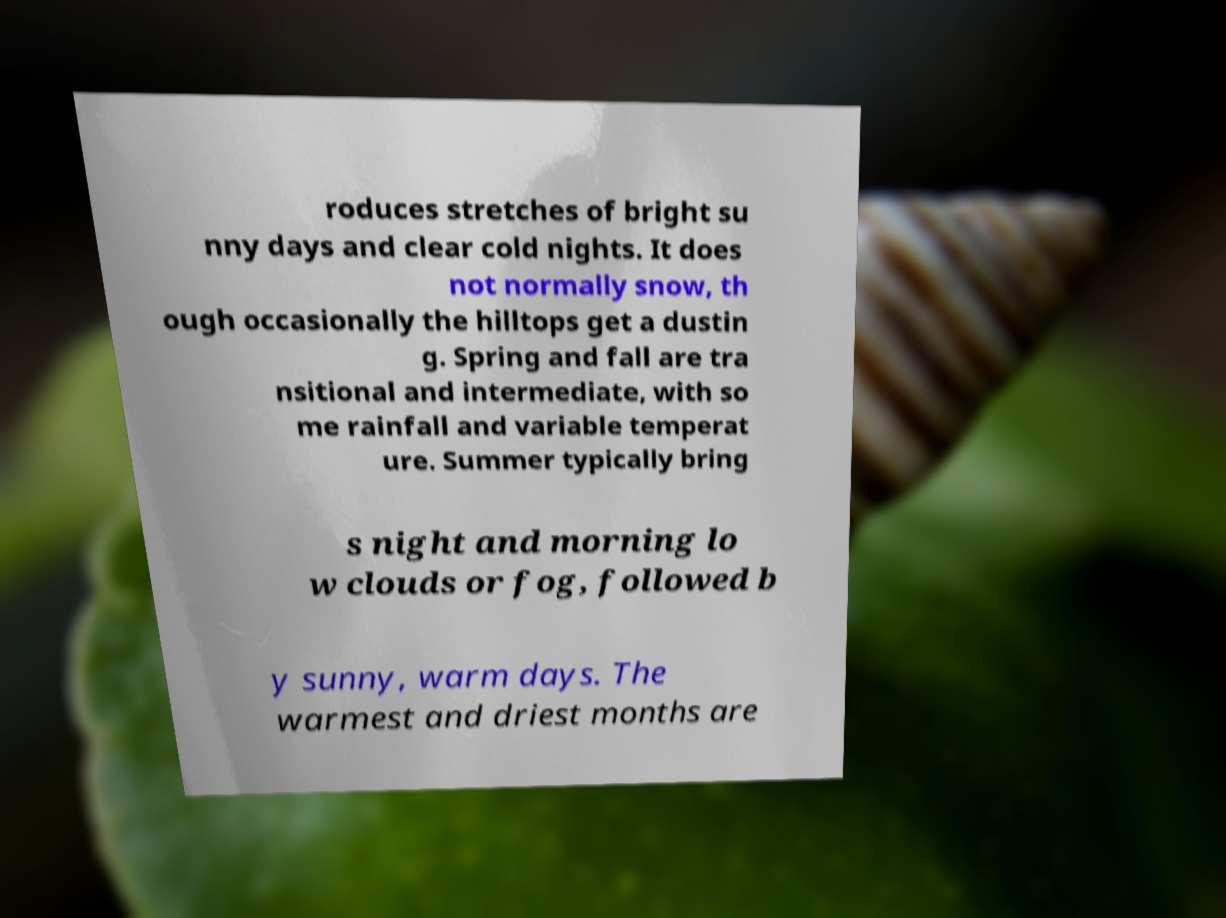There's text embedded in this image that I need extracted. Can you transcribe it verbatim? roduces stretches of bright su nny days and clear cold nights. It does not normally snow, th ough occasionally the hilltops get a dustin g. Spring and fall are tra nsitional and intermediate, with so me rainfall and variable temperat ure. Summer typically bring s night and morning lo w clouds or fog, followed b y sunny, warm days. The warmest and driest months are 